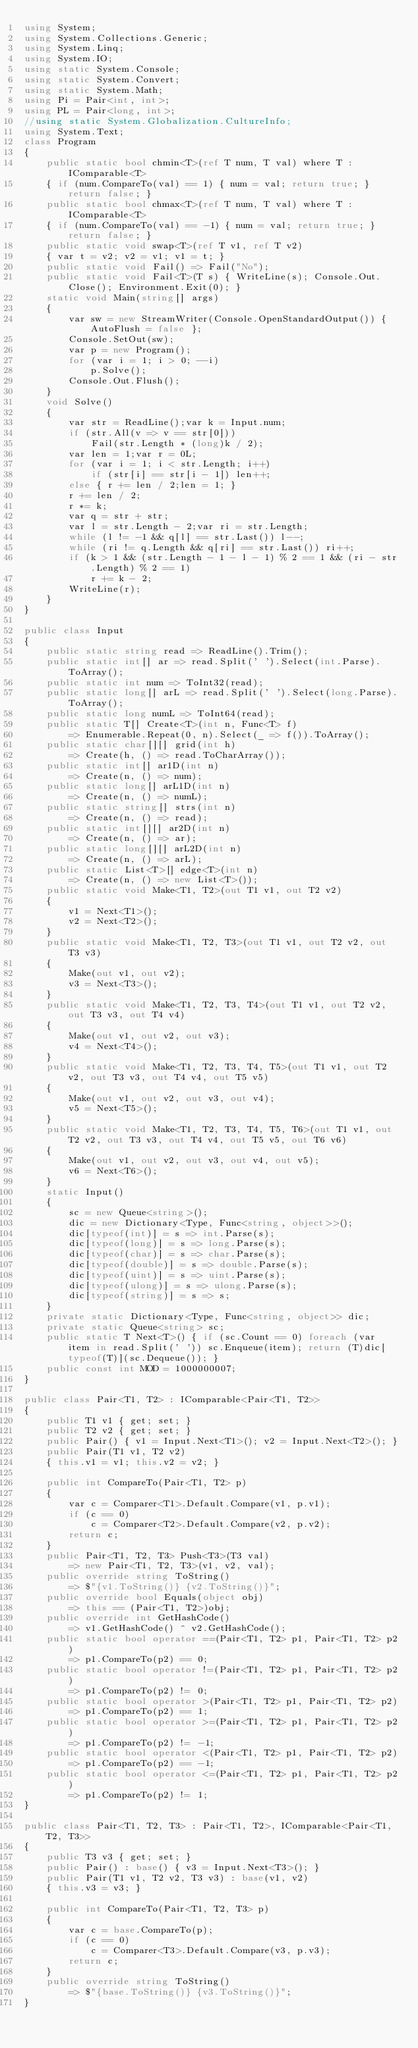Convert code to text. <code><loc_0><loc_0><loc_500><loc_500><_C#_>using System;
using System.Collections.Generic;
using System.Linq;
using System.IO;
using static System.Console;
using static System.Convert;
using static System.Math;
using Pi = Pair<int, int>;
using PL = Pair<long, int>;
//using static System.Globalization.CultureInfo;
using System.Text;
class Program
{
    public static bool chmin<T>(ref T num, T val) where T : IComparable<T>
    { if (num.CompareTo(val) == 1) { num = val; return true; } return false; }
    public static bool chmax<T>(ref T num, T val) where T : IComparable<T>
    { if (num.CompareTo(val) == -1) { num = val; return true; } return false; }
    public static void swap<T>(ref T v1, ref T v2)
    { var t = v2; v2 = v1; v1 = t; }
    public static void Fail() => Fail("No");
    public static void Fail<T>(T s) { WriteLine(s); Console.Out.Close(); Environment.Exit(0); }
    static void Main(string[] args)
    {
        var sw = new StreamWriter(Console.OpenStandardOutput()) { AutoFlush = false };
        Console.SetOut(sw);
        var p = new Program();
        for (var i = 1; i > 0; --i)
            p.Solve();
        Console.Out.Flush();
    }
    void Solve()
    {
        var str = ReadLine();var k = Input.num;
        if (str.All(v => v == str[0]))
            Fail(str.Length * (long)k / 2);
        var len = 1;var r = 0L;
        for (var i = 1; i < str.Length; i++)
            if (str[i] == str[i - 1]) len++;
        else { r += len / 2;len = 1; }
        r += len / 2;
        r *= k;
        var q = str + str;
        var l = str.Length - 2;var ri = str.Length;
        while (l != -1 && q[l] == str.Last()) l--;
        while (ri != q.Length && q[ri] == str.Last()) ri++;
        if (k > 1 && (str.Length - 1 - l - 1) % 2 == 1 && (ri - str.Length) % 2 == 1)
            r += k - 2;
        WriteLine(r);
    }
}

public class Input
{
    public static string read => ReadLine().Trim();
    public static int[] ar => read.Split(' ').Select(int.Parse).ToArray();
    public static int num => ToInt32(read);
    public static long[] arL => read.Split(' ').Select(long.Parse).ToArray();
    public static long numL => ToInt64(read);
    public static T[] Create<T>(int n, Func<T> f)
        => Enumerable.Repeat(0, n).Select(_ => f()).ToArray();
    public static char[][] grid(int h)
        => Create(h, () => read.ToCharArray());
    public static int[] ar1D(int n)
        => Create(n, () => num);
    public static long[] arL1D(int n)
        => Create(n, () => numL);
    public static string[] strs(int n)
        => Create(n, () => read);
    public static int[][] ar2D(int n)
        => Create(n, () => ar);
    public static long[][] arL2D(int n)
        => Create(n, () => arL);
    public static List<T>[] edge<T>(int n)
        => Create(n, () => new List<T>());
    public static void Make<T1, T2>(out T1 v1, out T2 v2)
    {
        v1 = Next<T1>();
        v2 = Next<T2>();
    }
    public static void Make<T1, T2, T3>(out T1 v1, out T2 v2, out T3 v3)
    {
        Make(out v1, out v2);
        v3 = Next<T3>();
    }
    public static void Make<T1, T2, T3, T4>(out T1 v1, out T2 v2, out T3 v3, out T4 v4)
    {
        Make(out v1, out v2, out v3);
        v4 = Next<T4>();
    }
    public static void Make<T1, T2, T3, T4, T5>(out T1 v1, out T2 v2, out T3 v3, out T4 v4, out T5 v5)
    {
        Make(out v1, out v2, out v3, out v4);
        v5 = Next<T5>();
    }
    public static void Make<T1, T2, T3, T4, T5, T6>(out T1 v1, out T2 v2, out T3 v3, out T4 v4, out T5 v5, out T6 v6)
    {
        Make(out v1, out v2, out v3, out v4, out v5);
        v6 = Next<T6>();
    }
    static Input()
    {
        sc = new Queue<string>();
        dic = new Dictionary<Type, Func<string, object>>();
        dic[typeof(int)] = s => int.Parse(s);
        dic[typeof(long)] = s => long.Parse(s);
        dic[typeof(char)] = s => char.Parse(s);
        dic[typeof(double)] = s => double.Parse(s);
        dic[typeof(uint)] = s => uint.Parse(s);
        dic[typeof(ulong)] = s => ulong.Parse(s);
        dic[typeof(string)] = s => s;
    }
    private static Dictionary<Type, Func<string, object>> dic;
    private static Queue<string> sc;
    public static T Next<T>() { if (sc.Count == 0) foreach (var item in read.Split(' ')) sc.Enqueue(item); return (T)dic[typeof(T)](sc.Dequeue()); }
    public const int MOD = 1000000007;
}

public class Pair<T1, T2> : IComparable<Pair<T1, T2>>
{
    public T1 v1 { get; set; }
    public T2 v2 { get; set; }
    public Pair() { v1 = Input.Next<T1>(); v2 = Input.Next<T2>(); }
    public Pair(T1 v1, T2 v2)
    { this.v1 = v1; this.v2 = v2; }

    public int CompareTo(Pair<T1, T2> p)
    {
        var c = Comparer<T1>.Default.Compare(v1, p.v1);
        if (c == 0)
            c = Comparer<T2>.Default.Compare(v2, p.v2);
        return c;
    }
    public Pair<T1, T2, T3> Push<T3>(T3 val)
        => new Pair<T1, T2, T3>(v1, v2, val);
    public override string ToString()
        => $"{v1.ToString()} {v2.ToString()}";
    public override bool Equals(object obj)
        => this == (Pair<T1, T2>)obj;
    public override int GetHashCode()
        => v1.GetHashCode() ^ v2.GetHashCode();
    public static bool operator ==(Pair<T1, T2> p1, Pair<T1, T2> p2)
        => p1.CompareTo(p2) == 0;
    public static bool operator !=(Pair<T1, T2> p1, Pair<T1, T2> p2)
        => p1.CompareTo(p2) != 0;
    public static bool operator >(Pair<T1, T2> p1, Pair<T1, T2> p2)
        => p1.CompareTo(p2) == 1;
    public static bool operator >=(Pair<T1, T2> p1, Pair<T1, T2> p2)
        => p1.CompareTo(p2) != -1;
    public static bool operator <(Pair<T1, T2> p1, Pair<T1, T2> p2)
        => p1.CompareTo(p2) == -1;
    public static bool operator <=(Pair<T1, T2> p1, Pair<T1, T2> p2)
        => p1.CompareTo(p2) != 1;
}

public class Pair<T1, T2, T3> : Pair<T1, T2>, IComparable<Pair<T1, T2, T3>>
{
    public T3 v3 { get; set; }
    public Pair() : base() { v3 = Input.Next<T3>(); }
    public Pair(T1 v1, T2 v2, T3 v3) : base(v1, v2)
    { this.v3 = v3; }

    public int CompareTo(Pair<T1, T2, T3> p)
    {
        var c = base.CompareTo(p);
        if (c == 0)
            c = Comparer<T3>.Default.Compare(v3, p.v3);
        return c;
    }
    public override string ToString()
        => $"{base.ToString()} {v3.ToString()}";
}
</code> 